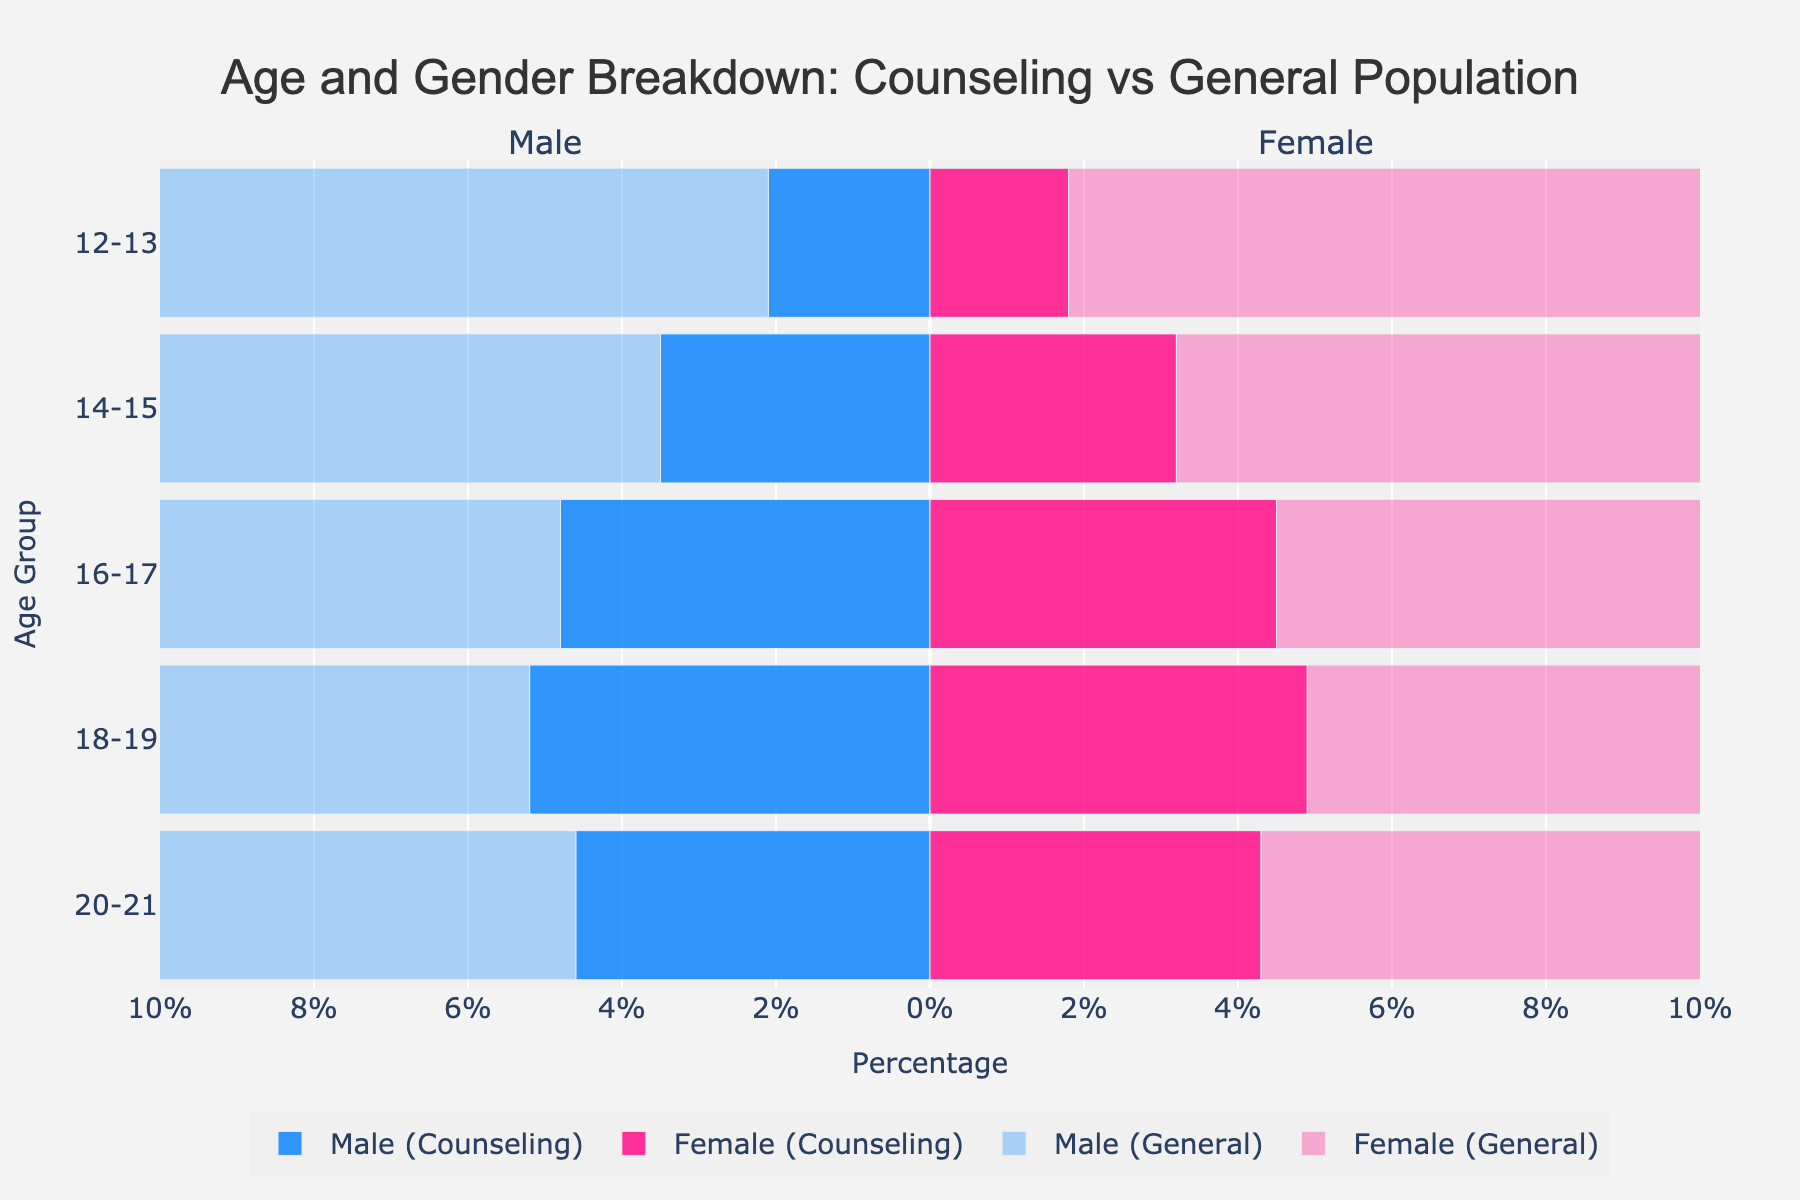Which age group has the highest percentage of males seeking counseling? Look at the bars representing 'Male (Counseling)' across different age groups. The bar corresponding to ages 18-19 has the highest percentage (5.2%).
Answer: 18-19 Which age group has the lowest percentage of females in the general population? Compare the bars for 'Female (General)' across age groups. The smallest bar is for ages 20-21, indicating the lowest percentage (7.1%).
Answer: 20-21 Are there more males or females in the general adolescent population within the 14-15 age group? Compare the 'Male (General)' and 'Female (General)' bars for the 14-15 age group. Both percentages are close, with males at 8.2% and females at 8.0%, making males slightly higher.
Answer: Males What is the total percentage of adolescents aged 16-17 seeking counseling? Add the percentages of 'Male (Counseling)' and 'Female (Counseling)' for ages 16-17. 4.8% (males) + 4.5% (females) = 9.3%.
Answer: 9.3% How does the percentage of females aged 12-13 seeking counseling compare to the general female population in the same age group? Compare the 'Female (Counseling)' bar for ages 12-13 (1.8%) with the 'Female (General)' bar for the same age group (8.3%). The counseling percentage is significantly lower.
Answer: Lower Are males or females seeking counseling more frequently in the 20-21 age group? Compare the 'Male (Counseling)' and 'Female (Counseling)' bars for ages 20-21. Males are at 4.6% and females at 4.3%, indicating males are slightly more frequent.
Answer: Males What is the overall trend in counseling rates for males as age increases from 12 to 21? Look at the bars for 'Male (Counseling)' across age groups from 12-13 to 20-21. The trend shows an increase up to 18-19 (5.2%) and then a slight decrease at 20-21 (4.6%).
Answer: Increasing then decreasing How does the counseling percentage of males aged 14-15 compare to that of females aged 18-19? Compare the 'Male (Counseling)' bar for ages 14-15 (3.5%) with the 'Female (Counseling)' bar for ages 18-19 (4.9%). The percentage for females aged 18-19 is higher.
Answer: Females aged 18-19 is higher Which group, male or female, has a more consistent trend in counseling percentages across all age groups? Observe the trend lines for 'Male (Counseling)' and 'Female (Counseling)' across all age groups. Both curves show similar trends, but the consistency can be seen more in females as both increase steadily to a peak and then slightly decrease.
Answer: Females What is the difference in the percentage of the general population between 12-13 and 20-21 for males? Subtract the percentage of ‘Male (General)’ in ages 20-21 (7.3%) from the percentage in ages 12-13 (8.5%). 8.5% - 7.3% = 1.2%.
Answer: 1.2% 